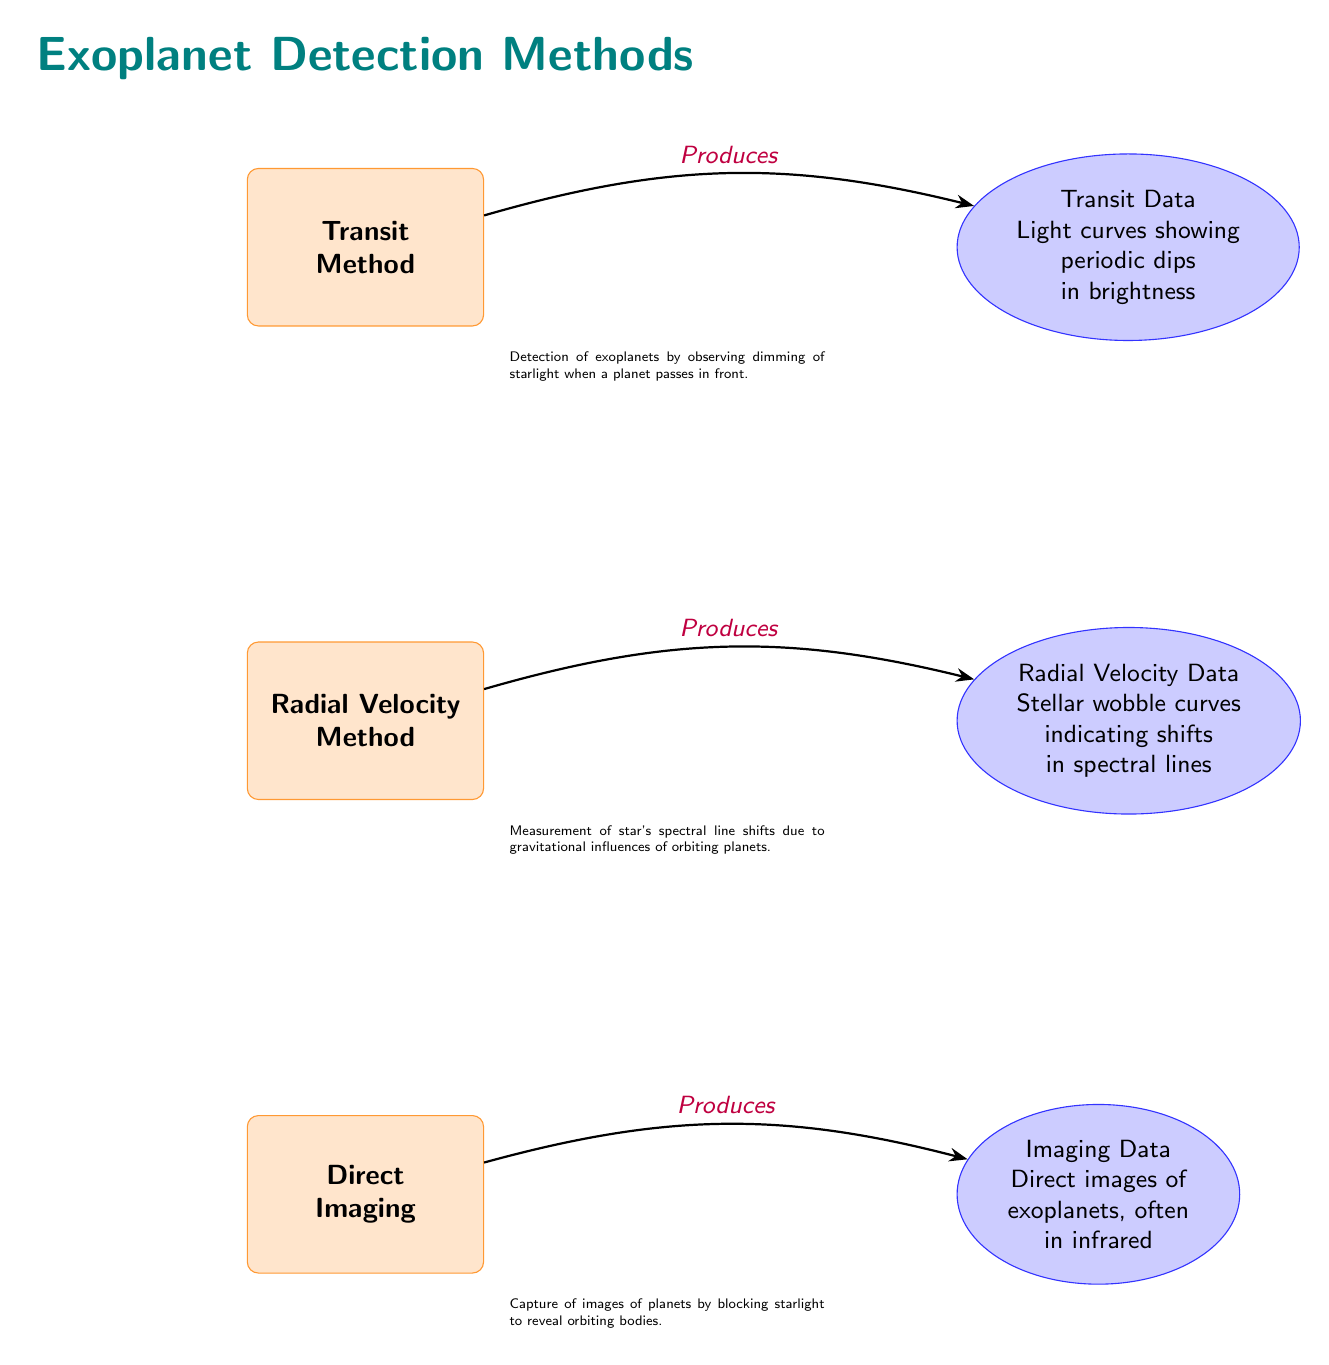What are the three methods of exoplanet detection shown in the diagram? The diagram displays three methods: Transit Method, Radial Velocity Method, and Direct Imaging. Each method is listed in rectangular nodes.
Answer: Transit Method, Radial Velocity Method, Direct Imaging What type of data does the Transit Method produce? According to the diagram, the Transit Method produces Transit Data, which includes light curves showing periodic dips in brightness. This data is directly indicated next to the Transit Method node.
Answer: Transit Data What does the Radial Velocity method measure? The diagram indicates that the Radial Velocity Method measures stellar wobble curves indicating shifts in spectral lines. This information can be found next to the Radial Velocity Method node in the diagram.
Answer: Stellar wobble curves How many detection methods are illustrated in the diagram? The diagram presents 3 detection methods: Transit Method, Radial Velocity Method, and Direct Imaging, as counted from the method nodes in the diagram.
Answer: 3 What output is generated by Direct Imaging? The output generated by Direct Imaging, as indicated in the diagram, is Imaging Data, which consists of direct images of exoplanets, often in infrared. This information is found next to the Direct Imaging node.
Answer: Imaging Data Which method involves the observation of starlight dimming? The diagram specifies that the Transit Method involves the observation of starlight dimming when a planet passes in front of its star; this information is part of the description under the Transit Method node.
Answer: Transit Method What do the arrows between methods and their respective data signify? The arrows in the diagram signify that each detection method produces a specific type of data. They point from the method nodes to the corresponding data nodes, illustrating the relationship between methods and their outputs.
Answer: Produces Which detection method is associated with capturing images of planets? The diagram identifies that Direct Imaging is associated with capturing images of planets, which is mentioned in the description next to the Direct Imaging node.
Answer: Direct Imaging What is the significance of the description associated with the Radial Velocity Method? The description associated with the Radial Velocity Method signifies that it measures shifts in spectral lines due to gravitational influences of orbiting planets. This information helps to understand how planets affect their parent stars.
Answer: Measurement of star's spectral line shifts 